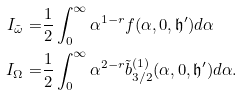<formula> <loc_0><loc_0><loc_500><loc_500>I _ { \tilde { \omega } } = & \frac { 1 } { 2 } \int _ { 0 } ^ { \infty } \alpha ^ { 1 - r } f ( \alpha , 0 , \mathfrak { h ^ { \prime } } ) d \alpha \\ I _ { \Omega } = & \frac { 1 } { 2 } \int _ { 0 } ^ { \infty } \alpha ^ { 2 - r } \tilde { b } ^ { ( 1 ) } _ { 3 / 2 } ( \alpha , 0 , \mathfrak { h ^ { \prime } } ) d \alpha .</formula> 